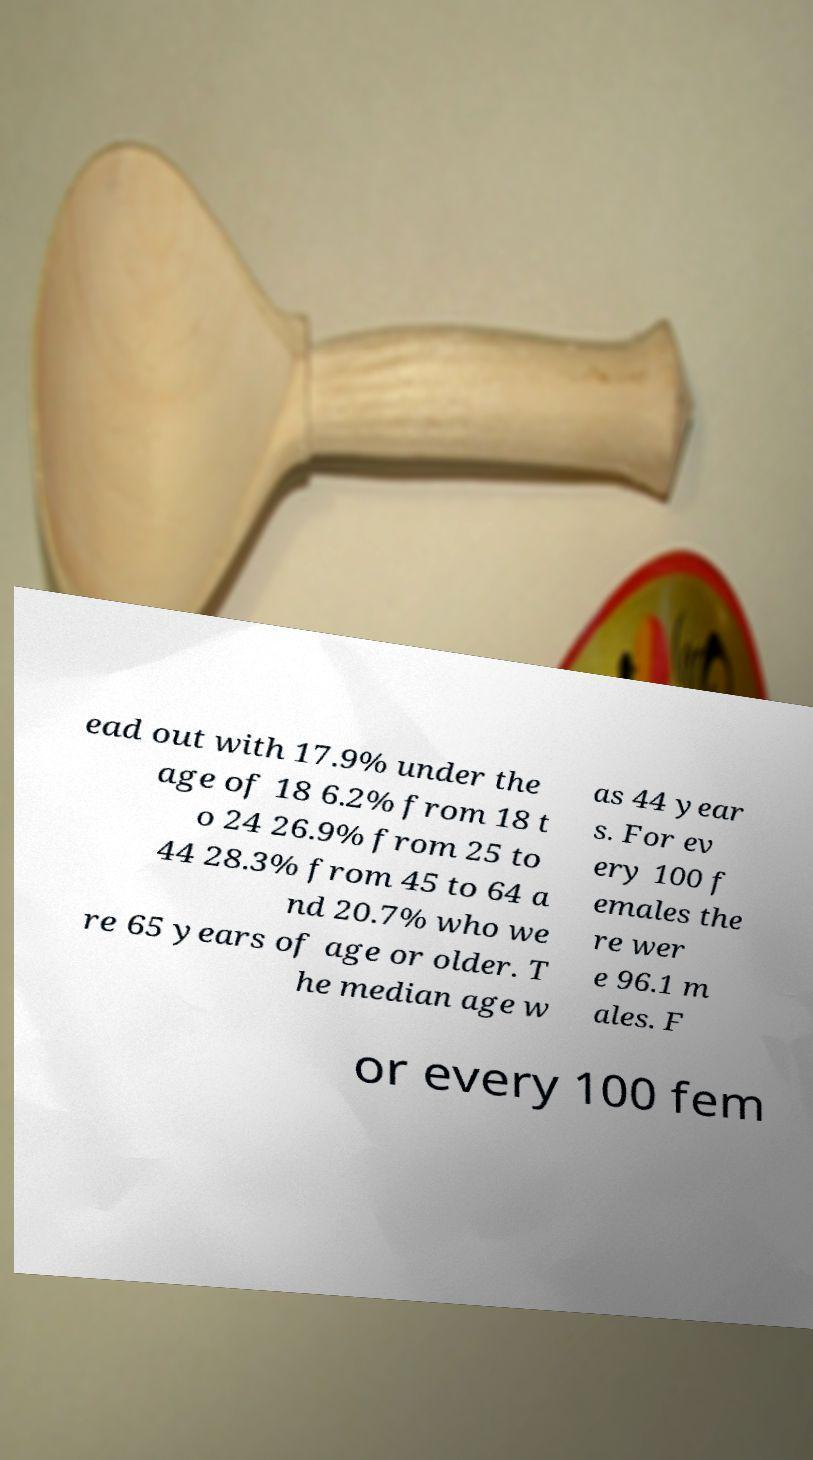Can you accurately transcribe the text from the provided image for me? ead out with 17.9% under the age of 18 6.2% from 18 t o 24 26.9% from 25 to 44 28.3% from 45 to 64 a nd 20.7% who we re 65 years of age or older. T he median age w as 44 year s. For ev ery 100 f emales the re wer e 96.1 m ales. F or every 100 fem 